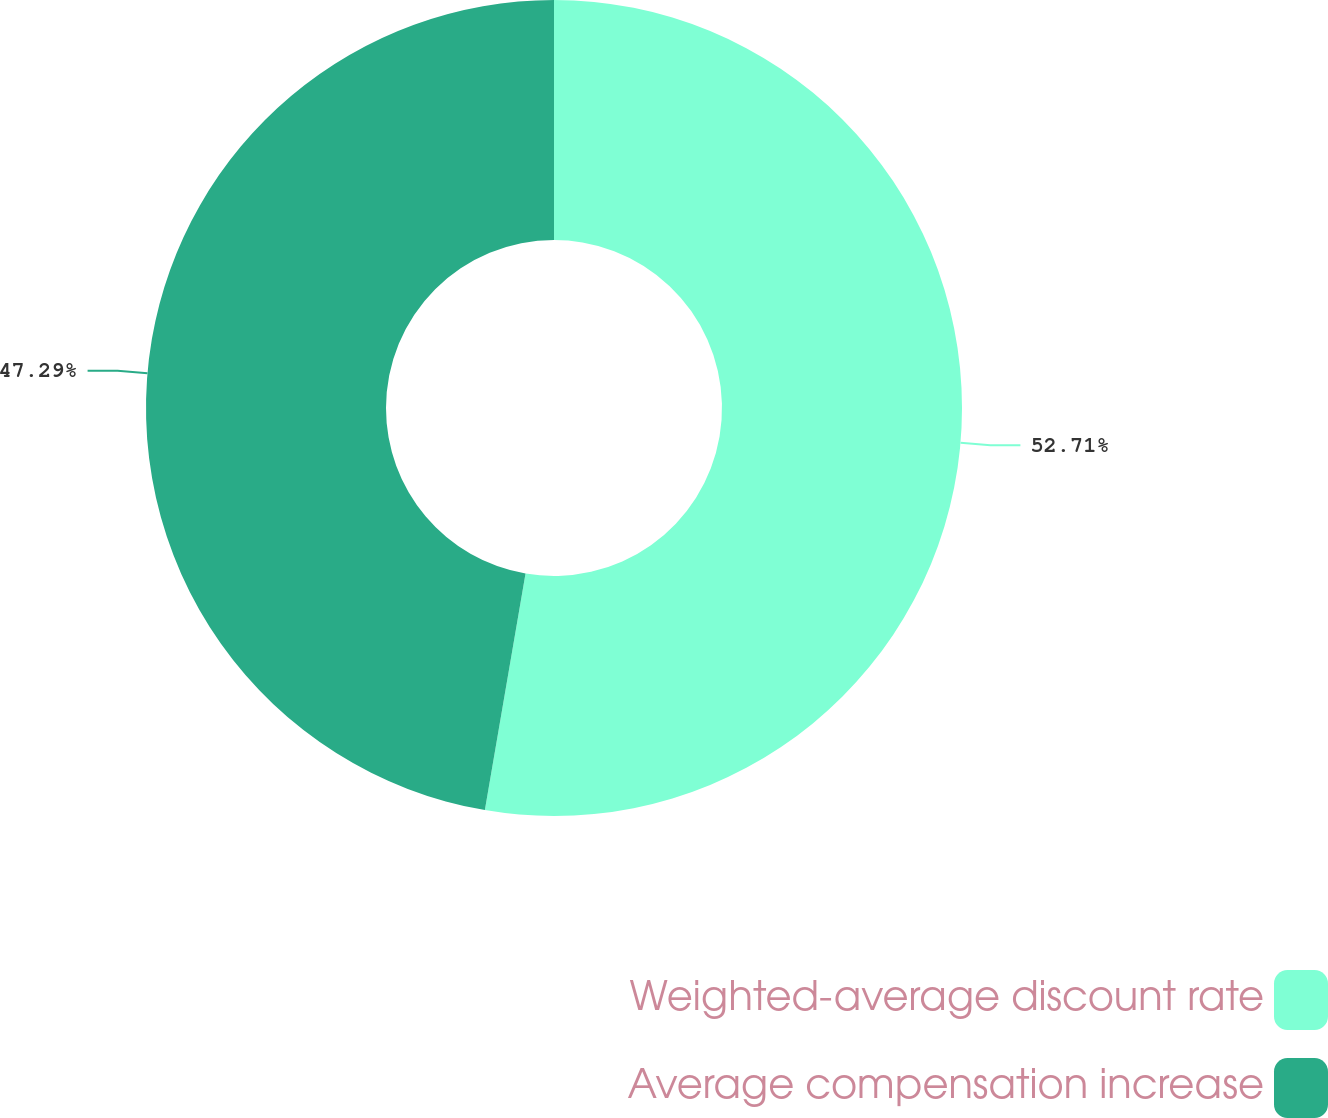<chart> <loc_0><loc_0><loc_500><loc_500><pie_chart><fcel>Weighted-average discount rate<fcel>Average compensation increase<nl><fcel>52.71%<fcel>47.29%<nl></chart> 